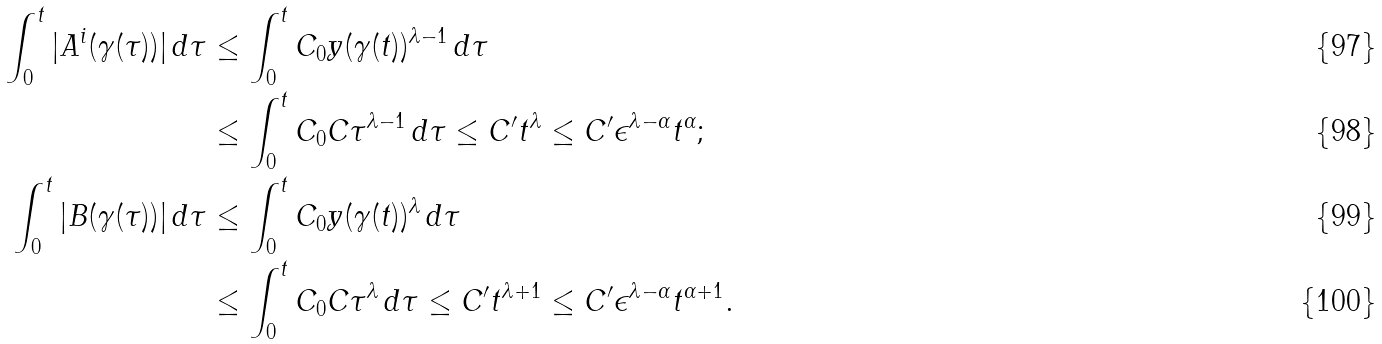<formula> <loc_0><loc_0><loc_500><loc_500>\int _ { 0 } ^ { t } | A ^ { i } ( \gamma ( \tau ) ) | \, d \tau & \leq \int _ { 0 } ^ { t } C _ { 0 } y ( \gamma ( t ) ) ^ { \lambda - 1 } \, d \tau \\ & \leq \int _ { 0 } ^ { t } C _ { 0 } C \tau ^ { \lambda - 1 } \, d \tau \leq C ^ { \prime } t ^ { \lambda } \leq C ^ { \prime } \epsilon ^ { \lambda - \alpha } t ^ { \alpha } ; \\ \int _ { 0 } ^ { t } | B ( \gamma ( \tau ) ) | \, d \tau & \leq \int _ { 0 } ^ { t } C _ { 0 } y ( \gamma ( t ) ) ^ { \lambda } \, d \tau \\ & \leq \int _ { 0 } ^ { t } C _ { 0 } C \tau ^ { \lambda } \, d \tau \leq C ^ { \prime } t ^ { \lambda + 1 } \leq C ^ { \prime } \epsilon ^ { \lambda - \alpha } t ^ { \alpha + 1 } .</formula> 